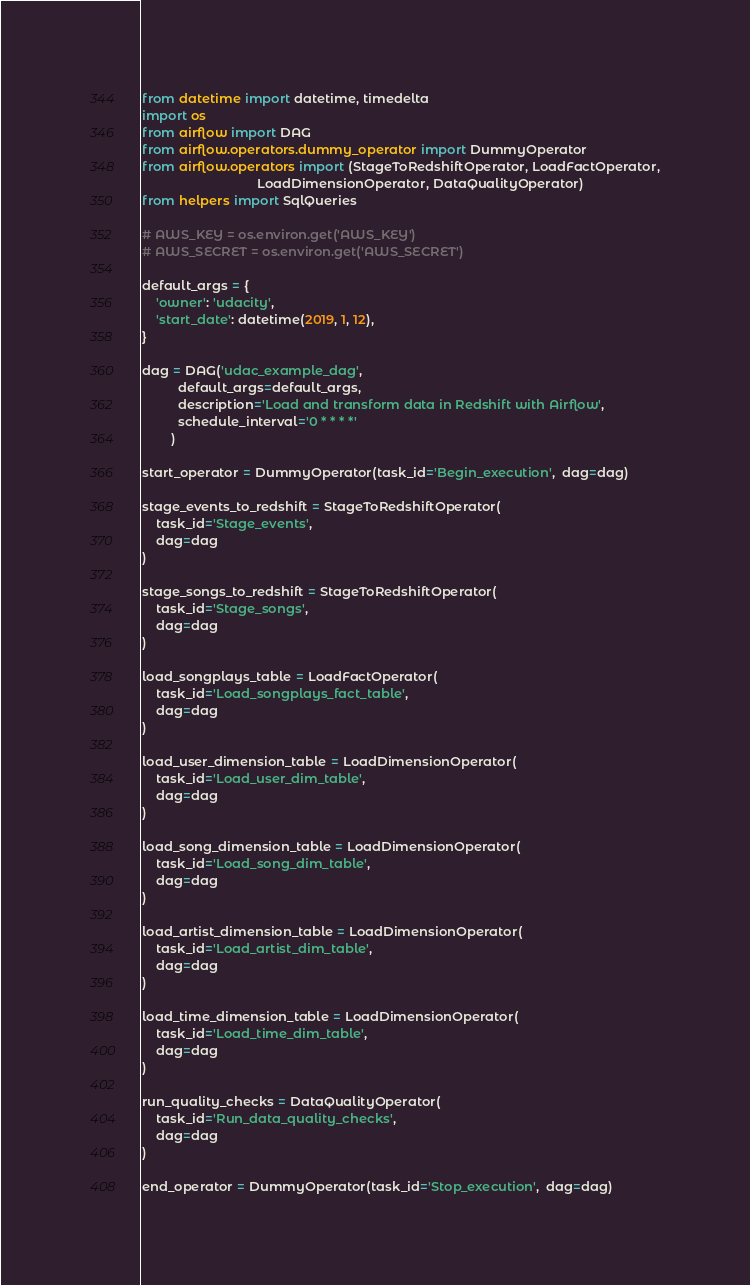<code> <loc_0><loc_0><loc_500><loc_500><_Python_>from datetime import datetime, timedelta
import os
from airflow import DAG
from airflow.operators.dummy_operator import DummyOperator
from airflow.operators import (StageToRedshiftOperator, LoadFactOperator,
                                LoadDimensionOperator, DataQualityOperator)
from helpers import SqlQueries

# AWS_KEY = os.environ.get('AWS_KEY')
# AWS_SECRET = os.environ.get('AWS_SECRET')

default_args = {
    'owner': 'udacity',
    'start_date': datetime(2019, 1, 12),
}

dag = DAG('udac_example_dag',
          default_args=default_args,
          description='Load and transform data in Redshift with Airflow',
          schedule_interval='0 * * * *'
        )

start_operator = DummyOperator(task_id='Begin_execution',  dag=dag)

stage_events_to_redshift = StageToRedshiftOperator(
    task_id='Stage_events',
    dag=dag
)

stage_songs_to_redshift = StageToRedshiftOperator(
    task_id='Stage_songs',
    dag=dag
)

load_songplays_table = LoadFactOperator(
    task_id='Load_songplays_fact_table',
    dag=dag
)

load_user_dimension_table = LoadDimensionOperator(
    task_id='Load_user_dim_table',
    dag=dag
)

load_song_dimension_table = LoadDimensionOperator(
    task_id='Load_song_dim_table',
    dag=dag
)

load_artist_dimension_table = LoadDimensionOperator(
    task_id='Load_artist_dim_table',
    dag=dag
)

load_time_dimension_table = LoadDimensionOperator(
    task_id='Load_time_dim_table',
    dag=dag
)

run_quality_checks = DataQualityOperator(
    task_id='Run_data_quality_checks',
    dag=dag
)

end_operator = DummyOperator(task_id='Stop_execution',  dag=dag)
</code> 